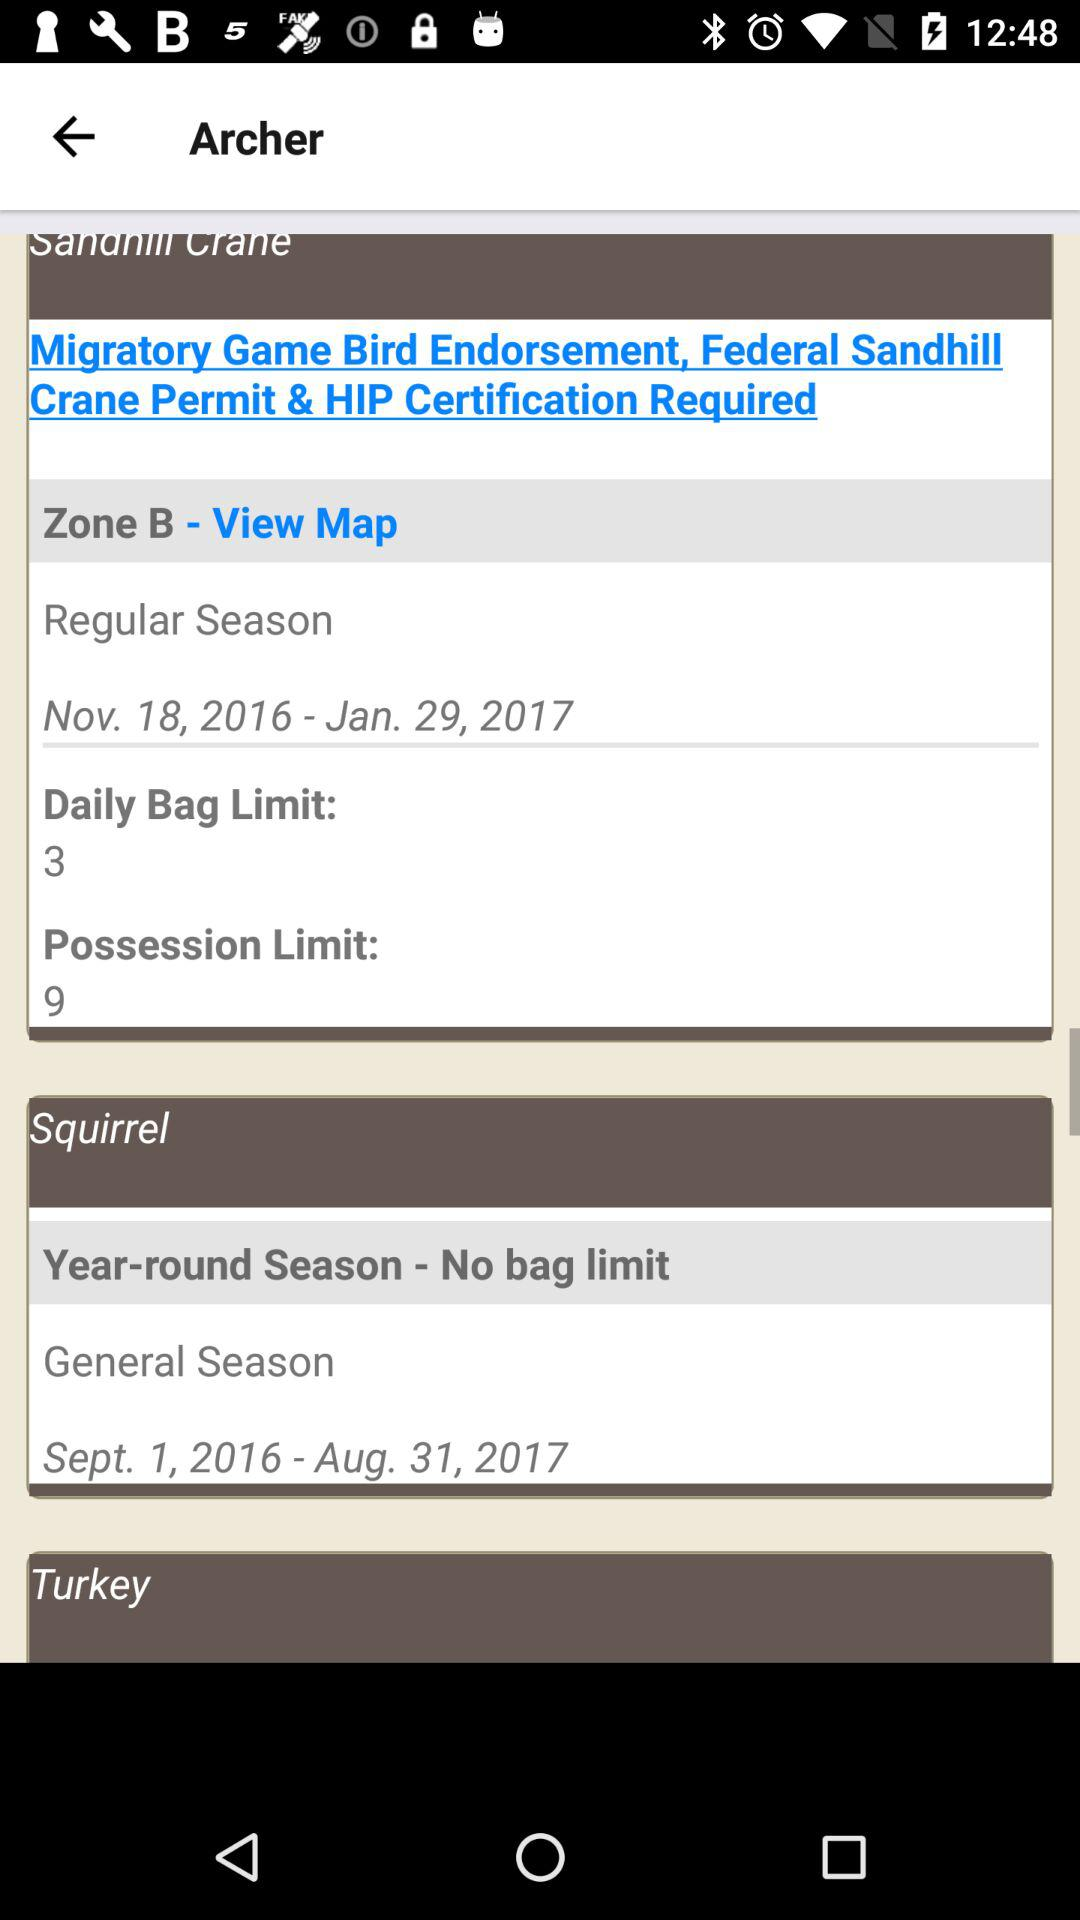What is the selected country?
When the provided information is insufficient, respond with <no answer>. <no answer> 